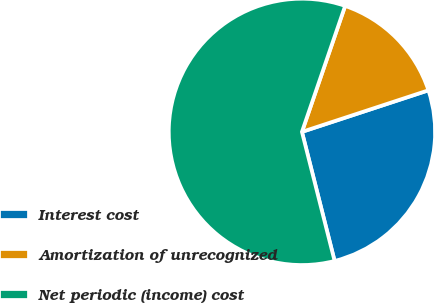Convert chart. <chart><loc_0><loc_0><loc_500><loc_500><pie_chart><fcel>Interest cost<fcel>Amortization of unrecognized<fcel>Net periodic (income) cost<nl><fcel>26.11%<fcel>14.69%<fcel>59.21%<nl></chart> 